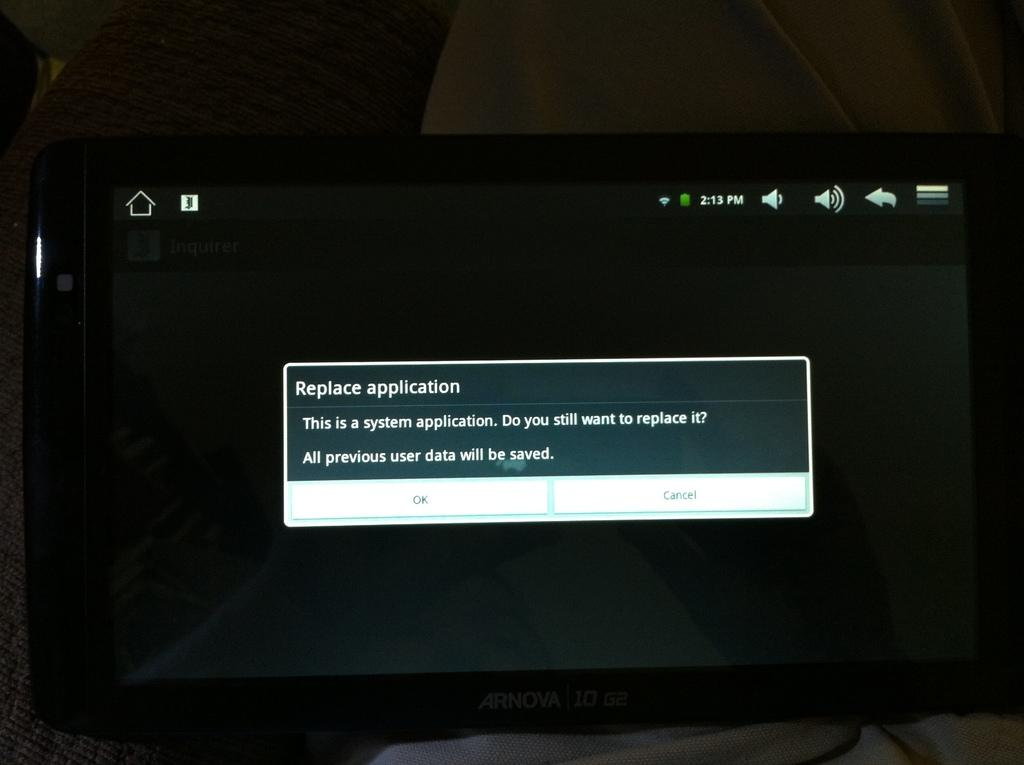<image>
Relay a brief, clear account of the picture shown. a warning screen reading "replace application"  on a black background 